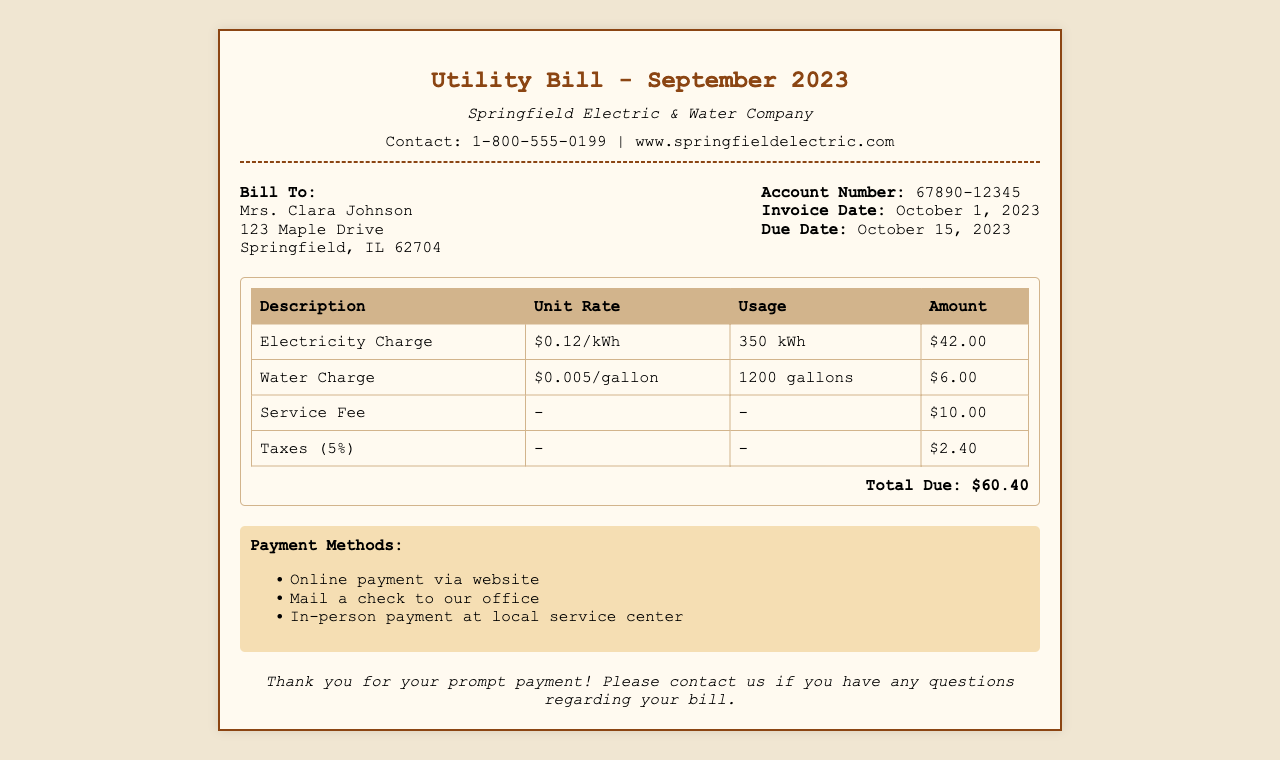What is the account number? The account number can be found in the bill information section of the document, which is 67890-12345.
Answer: 67890-12345 What is the total amount due? The total amount due is found in the charges section, which sums up all charges, amounting to $60.40.
Answer: $60.40 What is the due date? The due date is noted in the bill information section of the document, which is October 15, 2023.
Answer: October 15, 2023 Who is the utility provider? The utility provider is mentioned in the header of the document, which states Springfield Electric & Water Company.
Answer: Springfield Electric & Water Company How many gallons of water were used? The usage statistics for water is presented in the charges section of the document, indicating that 1200 gallons were used.
Answer: 1200 gallons What is the service fee amount? The service fee is detailed in the charges table, which shows the amount to be $10.00.
Answer: $10.00 What percentage is applied for taxes? The tax percentage is stated in the charges section, which notes a tax rate of 5%.
Answer: 5% What is the electricity charge per kilowatt-hour? The electricity charge rate can be found in the charges table, which states it as $0.12 per kWh.
Answer: $0.12/kWh How can payments be made? Payment methods are outlined in their respective section, indicating several ways to pay including online, by mail, and in-person.
Answer: Online payment, Mail a check, In-person payment 